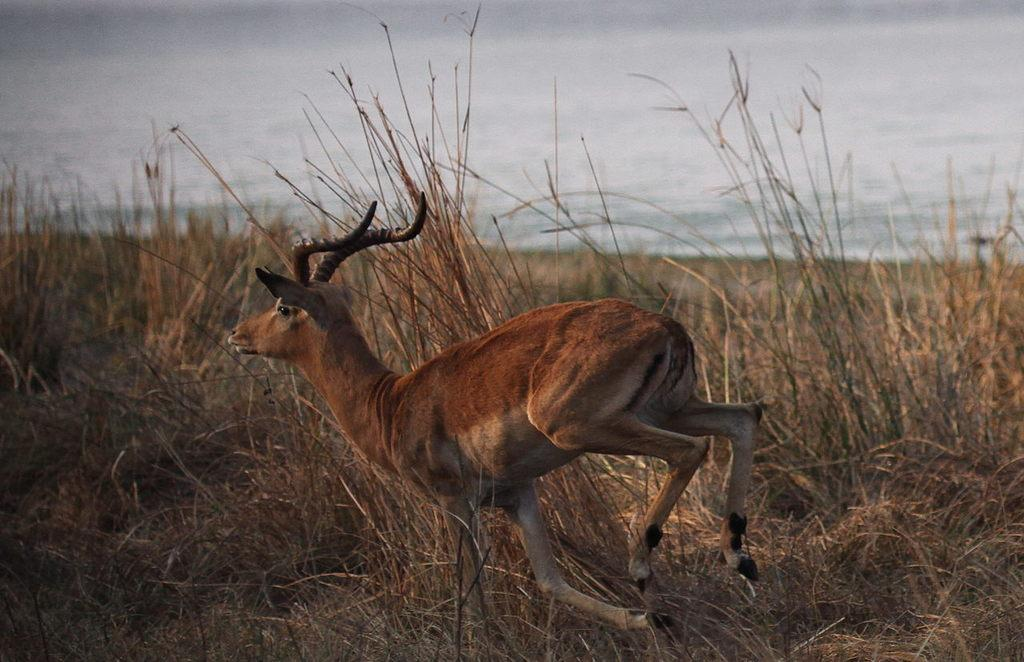What animal can be seen in the image? There is a deer in the image. What is the deer's position in the image? The deer is standing on the ground. What type of vegetation is visible in the background of the image? There is grass in the background of the image. What part of the natural environment is visible in the background of the image? The sky is visible in the background of the image. What hand gesture is the deer making in the image? There is no hand gesture present in the image, as the subject is a deer, which does not have hands. 